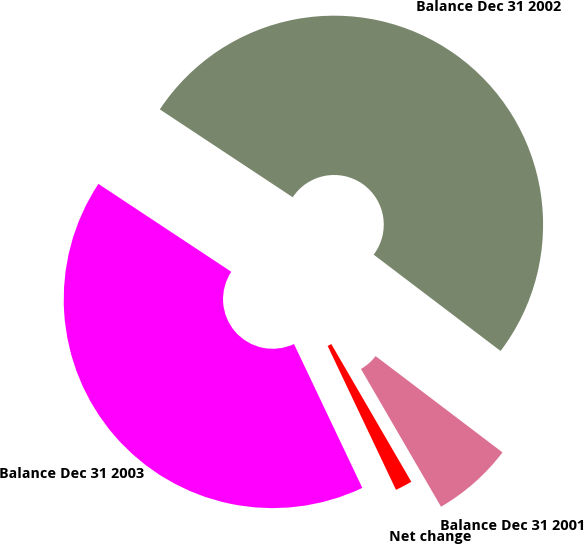Convert chart. <chart><loc_0><loc_0><loc_500><loc_500><pie_chart><fcel>Net change<fcel>Balance Dec 31 2001<fcel>Balance Dec 31 2002<fcel>Balance Dec 31 2003<nl><fcel>1.32%<fcel>6.29%<fcel>51.04%<fcel>41.36%<nl></chart> 